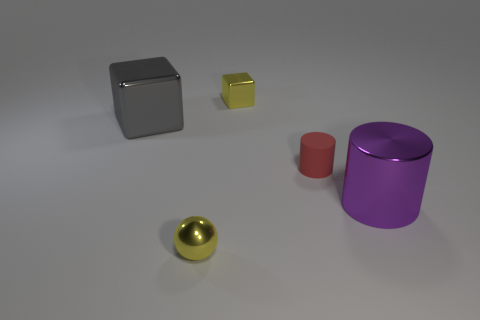Add 2 tiny red rubber things. How many objects exist? 7 Subtract all cubes. How many objects are left? 3 Add 3 blue metallic spheres. How many blue metallic spheres exist? 3 Subtract 0 cyan cubes. How many objects are left? 5 Subtract all green shiny balls. Subtract all big purple objects. How many objects are left? 4 Add 1 purple metal cylinders. How many purple metal cylinders are left? 2 